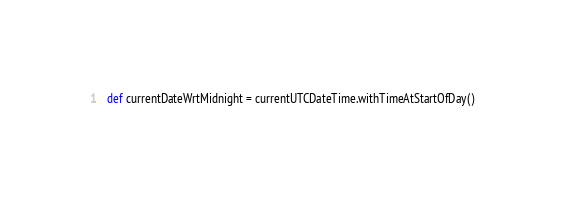<code> <loc_0><loc_0><loc_500><loc_500><_Scala_>  def currentDateWrtMidnight = currentUTCDateTime.withTimeAtStartOfDay()
</code> 